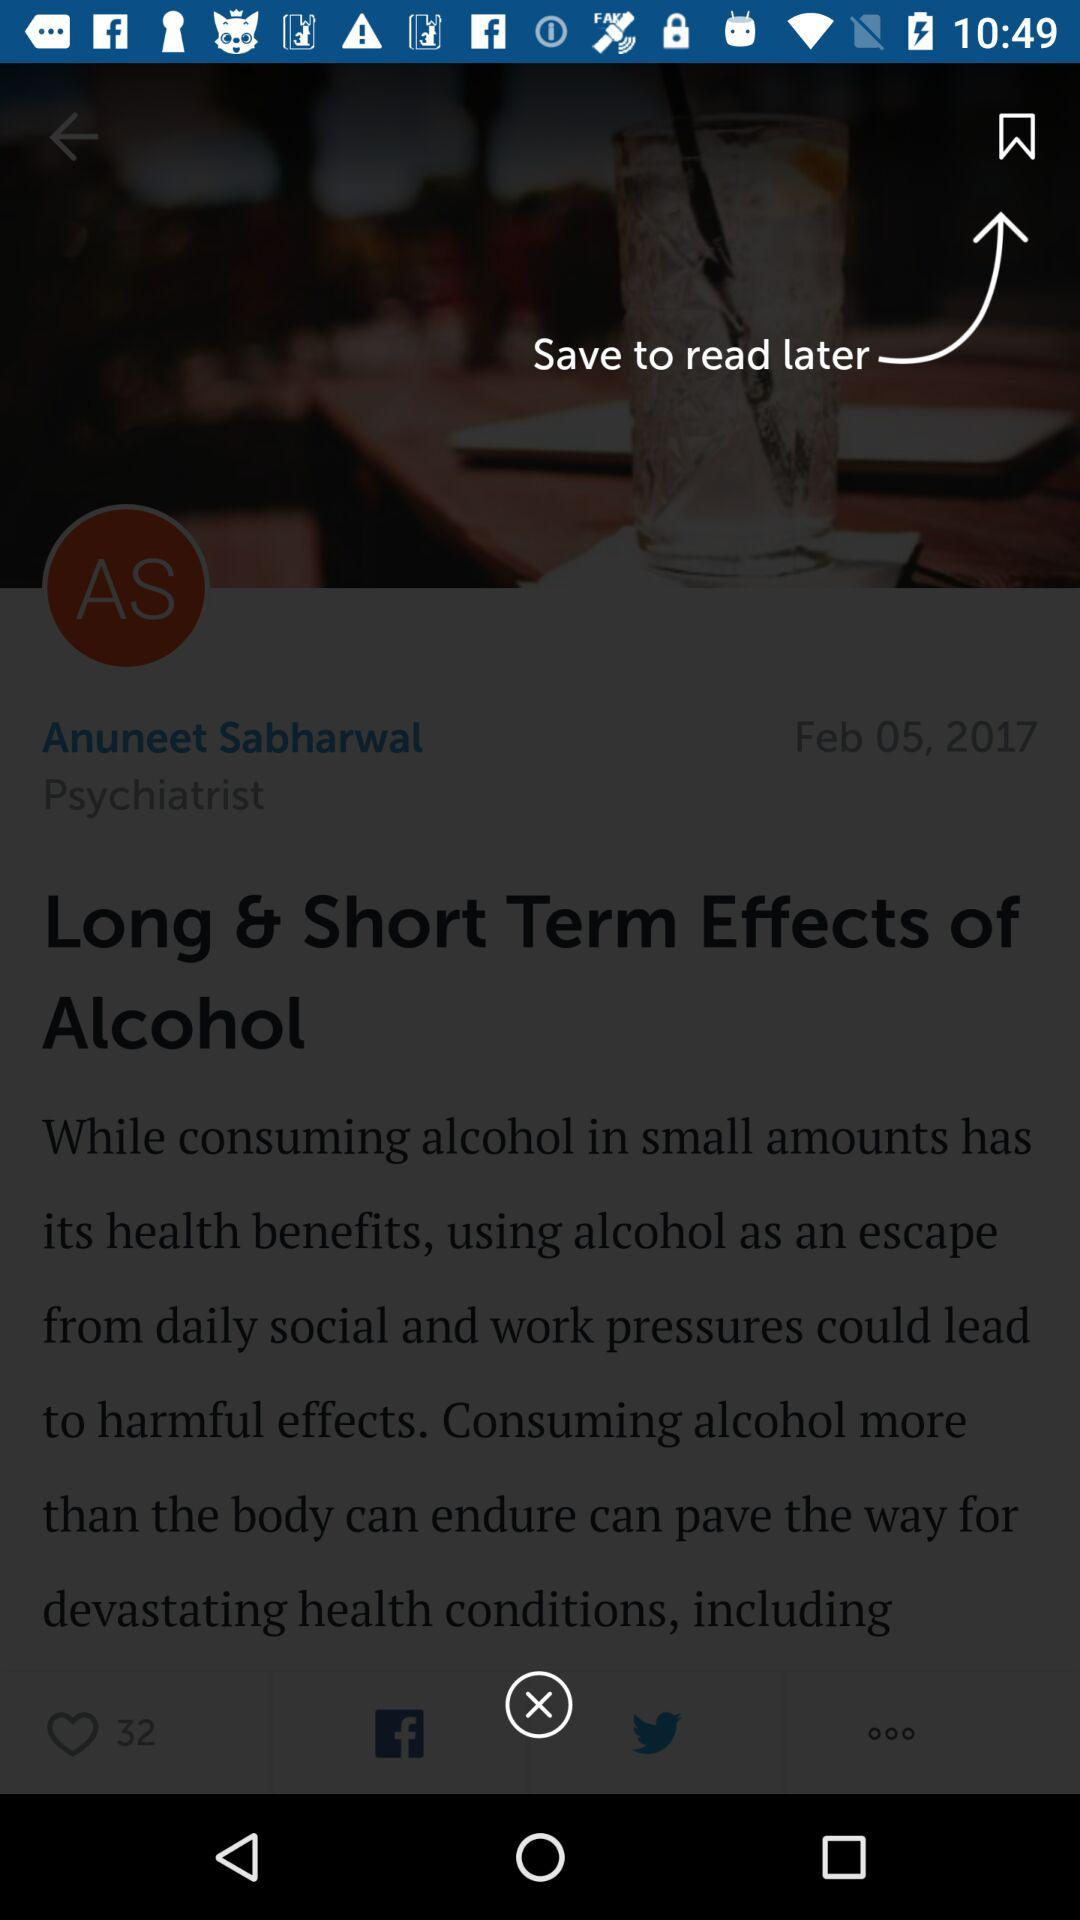Who is the psychiatrist? The psychiatrist is Anuneet Sabharwal. 